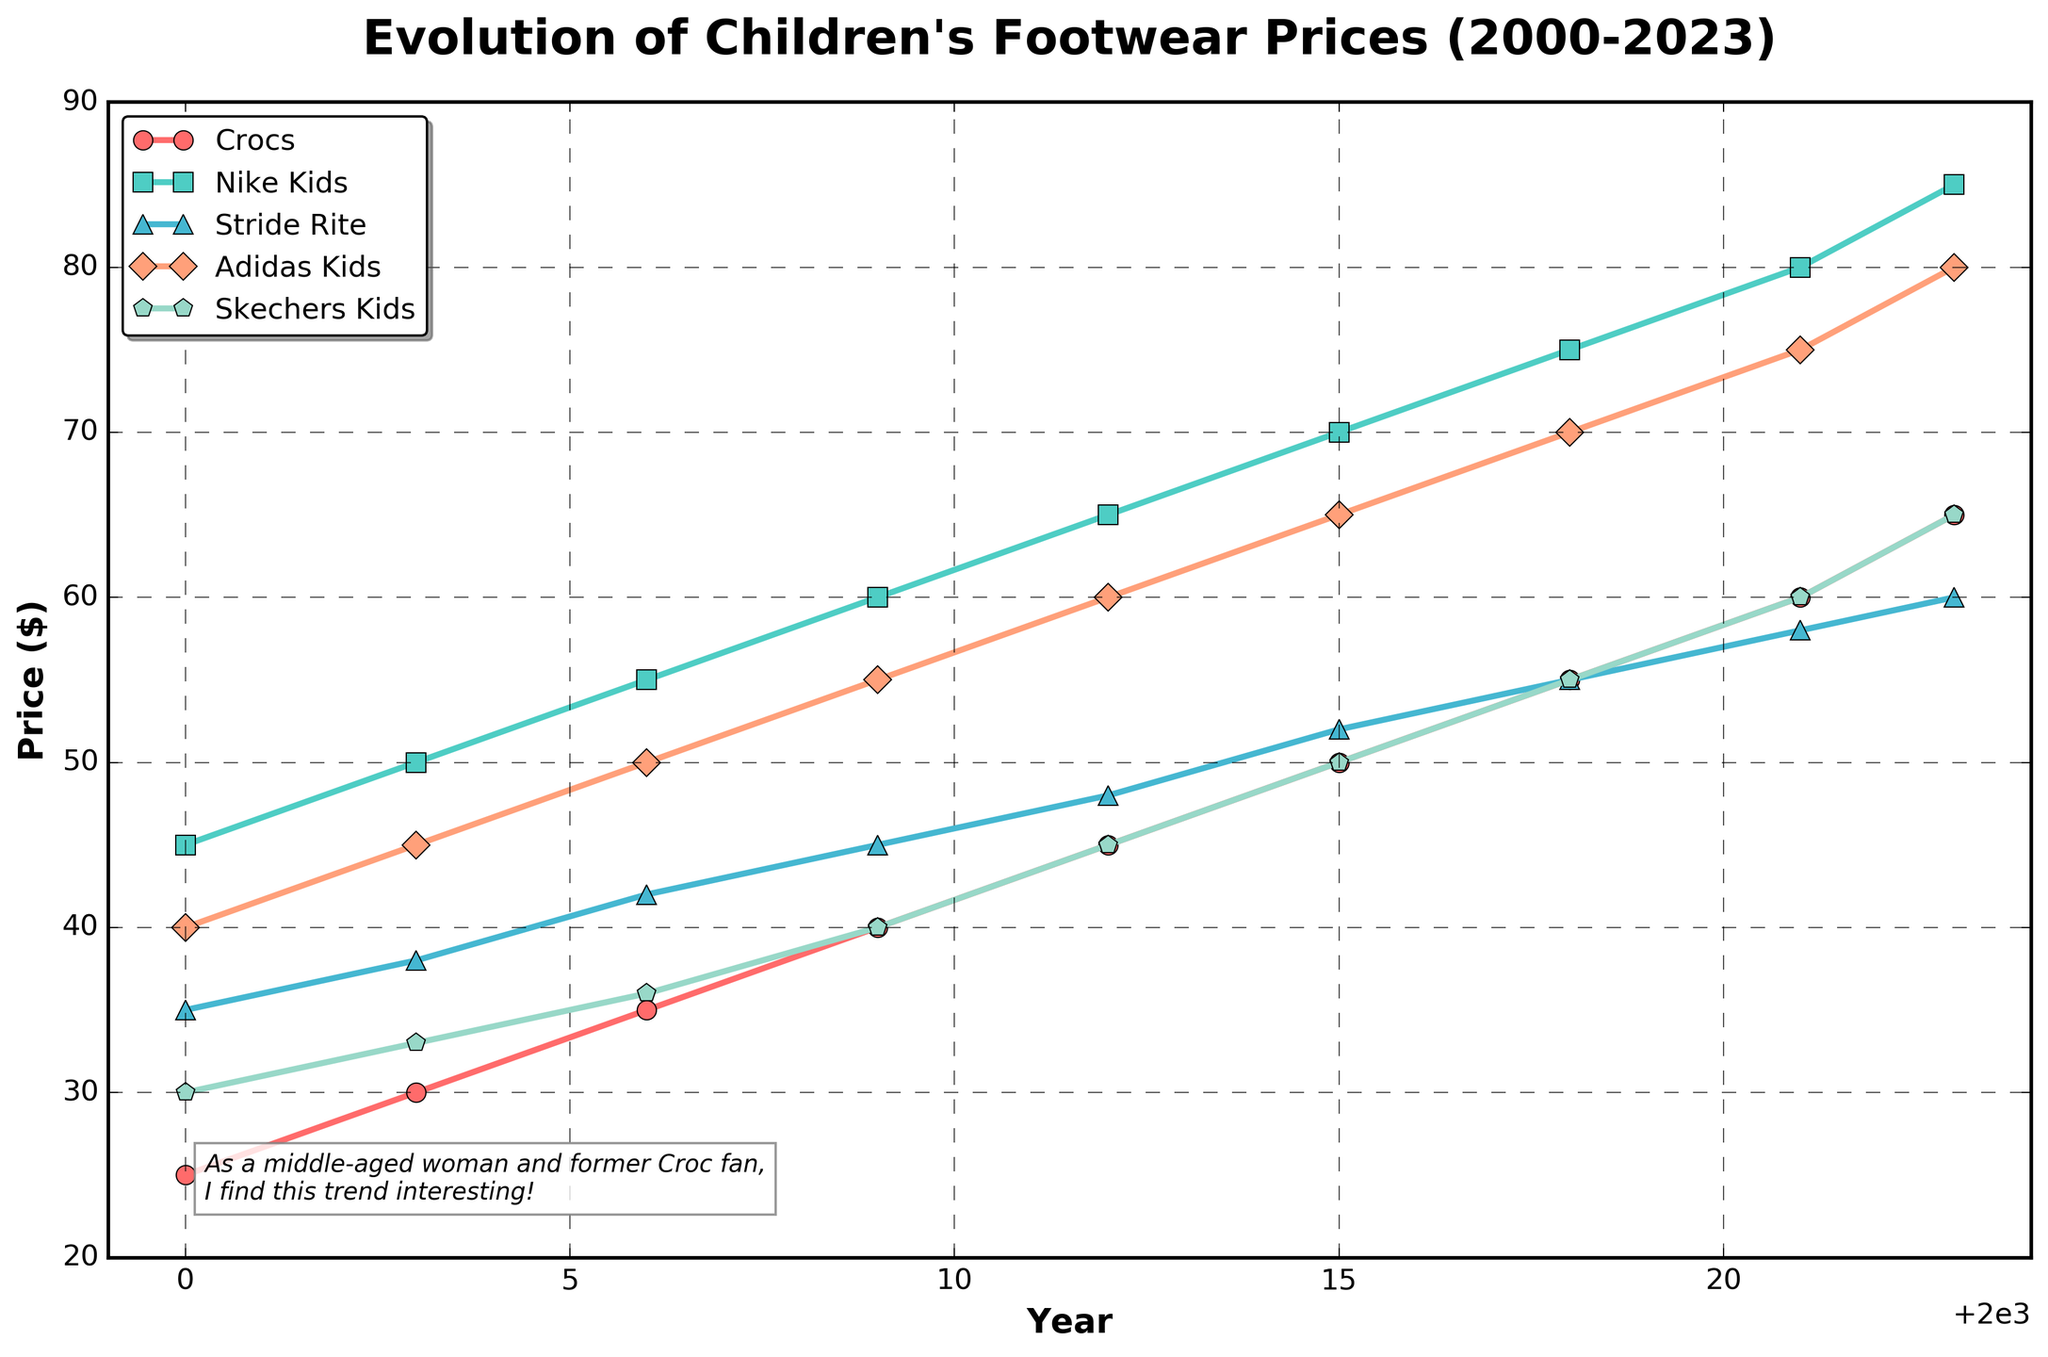What was the price of Crocs in 2009? Look for the data point corresponding to the line labeled "Crocs" at the year 2009.
Answer: 40 dollars Which brand had the highest price increase from 2000 to 2023? To determine the highest price increase, subtract the 2000 price from the 2023 price for each brand and compare the results. Crocs: 65 - 25 = 40, Nike Kids: 85 - 45 = 40, Stride Rite: 60 - 35 = 25, Adidas Kids: 80 - 40 = 40, Skechers Kids: 65 - 30 = 35. The highest increases are 40 dollars for Crocs, Nike Kids, and Adidas Kids.
Answer: Crocs, Nike Kids, and Adidas Kids Which footwear brand had the highest price in 2023? Look at the topmost data point for the year 2023 across all lines.
Answer: Nike Kids How much did the price of Stride Rite increase from 2006 to 2015? Subtract the price in 2006 from the price in 2015 for Stride Rite. 52 - 42 = 10 dollars.
Answer: 10 dollars What is the average price of Skechers Kids footwear over the years 2000, 2006, and 2012? Add the prices of Skechers Kids in 2000, 2006, and 2012 and then divide by 3. (30 + 36 + 45) / 3 = 111 / 3 = 37 dollars.
Answer: 37 dollars Which brand showed consistent price increases every year? Observe the trend lines for each brand and check if the prices are consistently increasing from one year to the next. All brands show consistent price increases.
Answer: All brands Between 2018 and 2021, which brand had the smallest price increase? Calculate the price difference between 2018 and 2021 for each brand and find the smallest increase. Crocs: 60 - 55 = 5, Nike Kids: 80 - 75 = 5, Stride Rite: 58 - 55 = 3, Adidas Kids: 75 - 70 = 5, Skechers Kids: 60 - 55 = 5. The smallest increase is 3 dollars for Stride Rite.
Answer: Stride Rite Which year did Crocs reach the $50 price mark? Look for the data point on the Crocs line that reaches or crosses the $50 price.
Answer: 2015 What was the price difference between the cheapest and the most expensive footwear brand in 2003? Find the lowest and highest prices in 2003, then subtract the lowest from the highest. The lowest price is 30 dollars (Crocs), and the highest is 50 dollars (Nike Kids). 50 - 30 = 20 dollars.
Answer: 20 dollars 